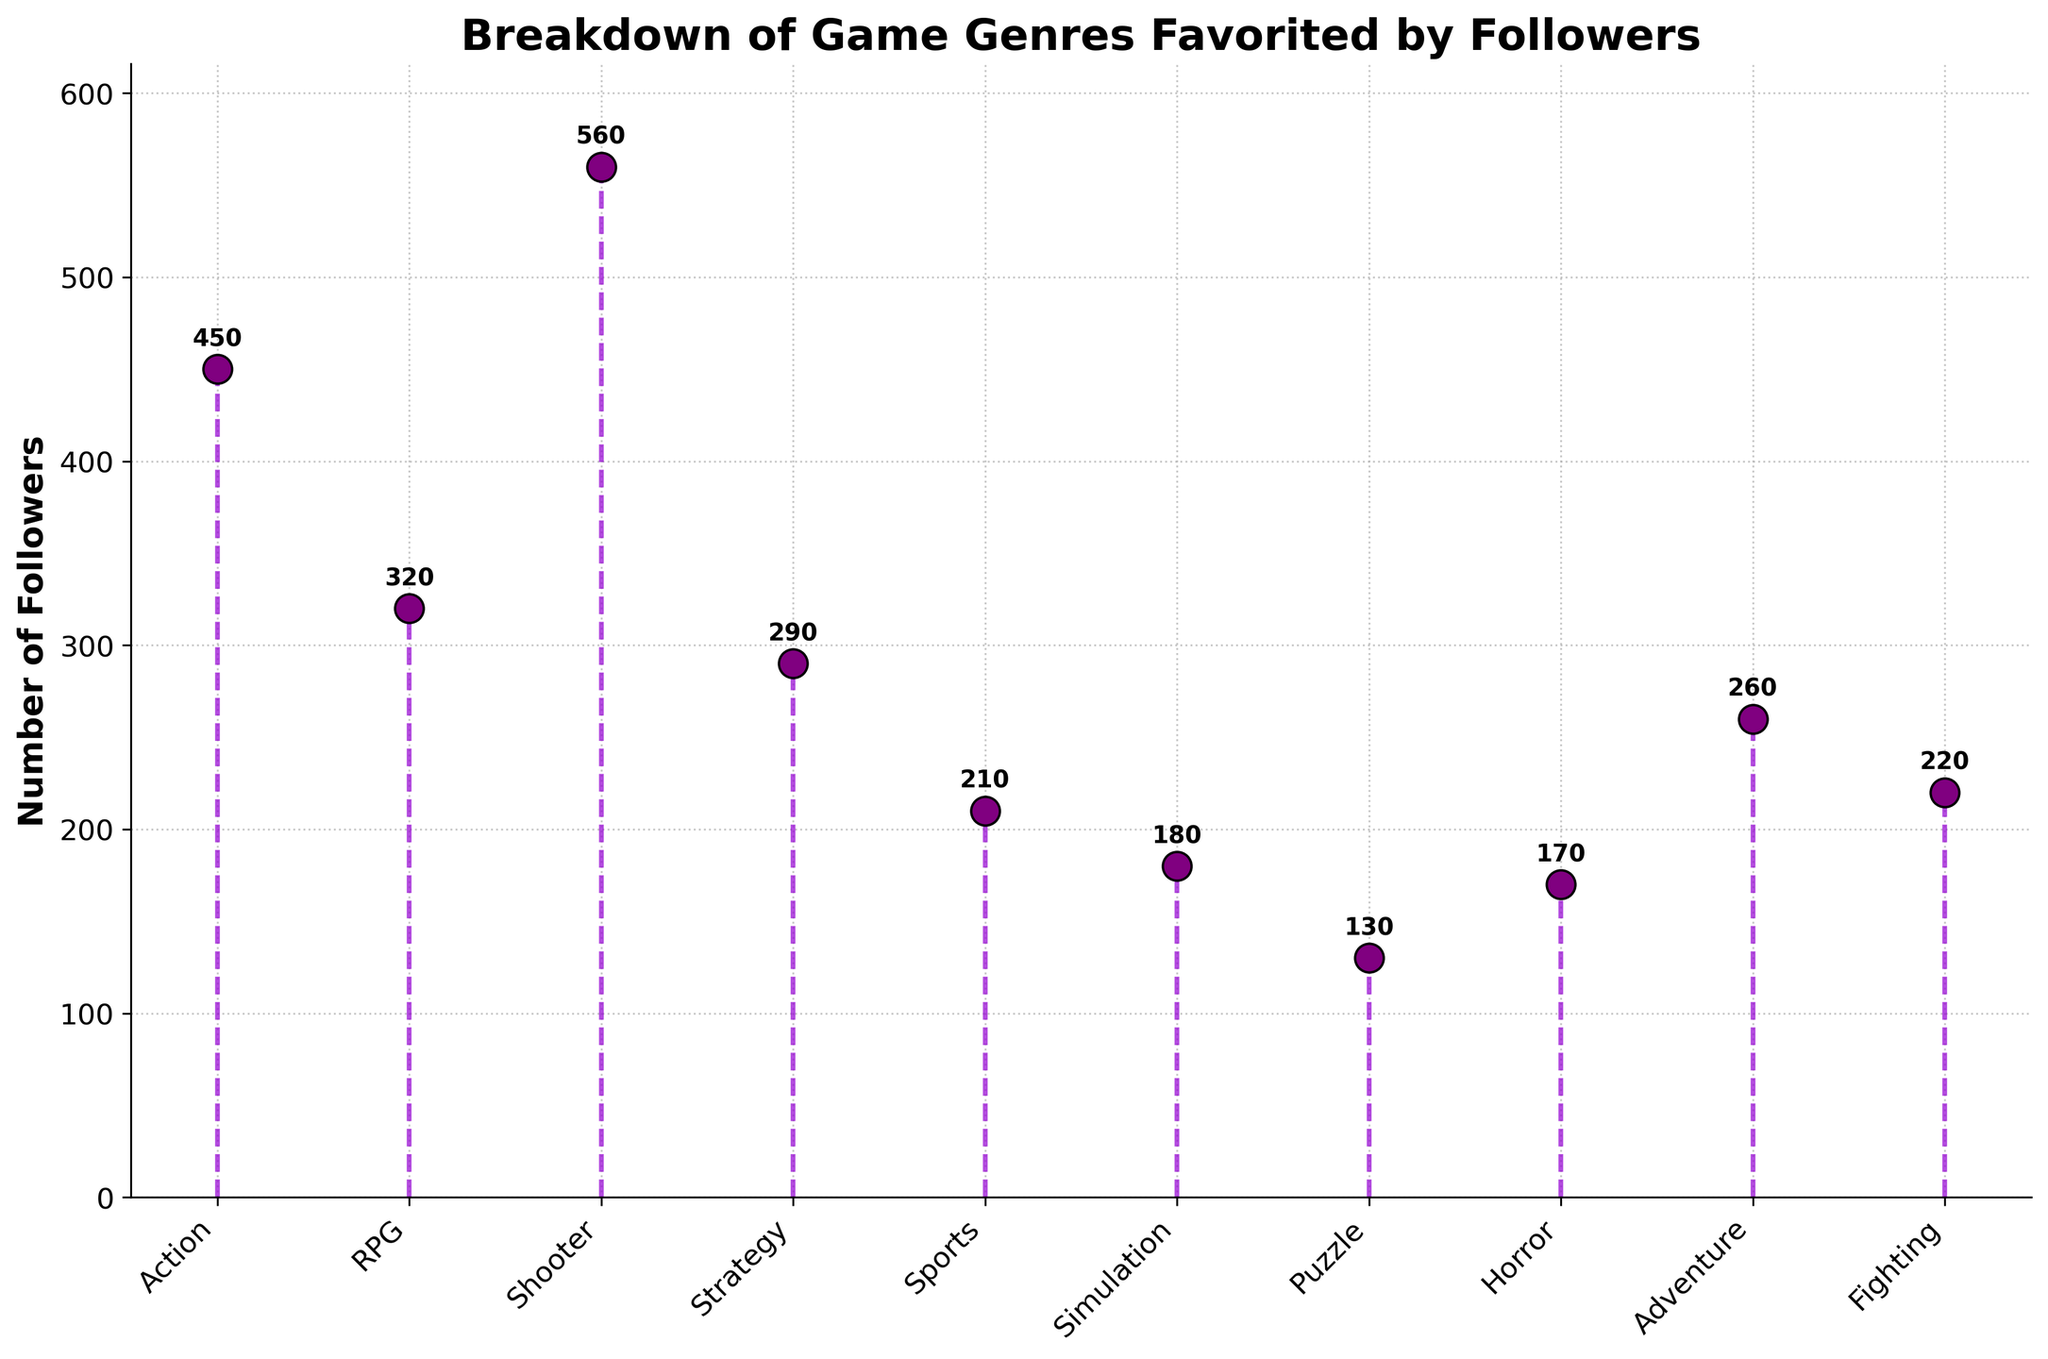Which game genre is favored by the highest number of followers? By looking at the stem plot, the genre with the highest follower count is identified at the tallest stem. The Shooter genre has the tallest stem.
Answer: Shooter What is the total number of followers for the Action and RPG genres combined? First, find the number of followers for Action and RPG from the plot. Action has 450 followers, and RPG has 320. Add these numbers together: 450 + 320 = 770
Answer: 770 Which genre has fewer followers: Sports or Simulation? Compare the heights of the stems for Sports and Simulation. Sports has 210 followers, while Simulation has 180 followers. Since 210 is greater than 180, Simulation has fewer followers.
Answer: Simulation How many followers favor the Horror genre? Look at the stem plot and find the number at the top of the stem corresponding to the Horror genre. The text annotation shows 170 followers.
Answer: 170 What is the average number of followers for the Strategy and Adventure genres? The stem for Strategy shows 290 followers, and the stem for Adventure shows 260 followers. Calculate the average: (290 + 260) / 2 = 275
Answer: 275 Are there more followers favoring the Puzzle genre than the Fighting genre? Compare the follower counts shown in the plot for Puzzle and Fighting. Puzzle has 130 followers, and Fighting has 220 followers. Since 130 < 220, there are fewer followers for Puzzle.
Answer: No What is the total number of followers across all genres? Add up the follower counts for all genres as displayed in the plot: 450 + 320 + 560 + 290 + 210 + 180 + 130 + 170 + 260 + 220 = 2790
Answer: 2790 Which genre has the shortest stem in the plot? The shortest stem in the plot corresponds to the Puzzle genre, which has 130 followers.
Answer: Puzzle By how much does the number of followers for the Shooter genre exceed those of the Sports genre? The Shooter genre has 560 followers, and the Sports genre has 210. Subtract the Sports follower count from the Shooter follower count: 560 - 210 = 350
Answer: 350 What is the difference in the number of followers between the Adventure and Fighting genres? Find the follower counts for Adventure (260) and Fighting (220). Calculate the difference: 260 - 220 = 40
Answer: 40 